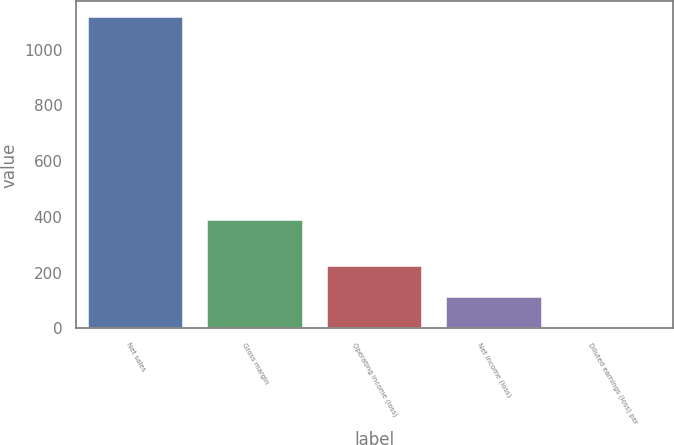Convert chart. <chart><loc_0><loc_0><loc_500><loc_500><bar_chart><fcel>Net sales<fcel>Gross margin<fcel>Operating income (loss)<fcel>Net income (loss)<fcel>Diluted earnings (loss) per<nl><fcel>1116.8<fcel>387.9<fcel>223.47<fcel>111.8<fcel>0.13<nl></chart> 